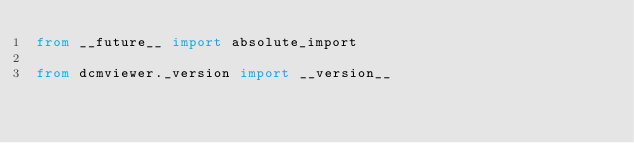<code> <loc_0><loc_0><loc_500><loc_500><_Python_>from __future__ import absolute_import

from dcmviewer._version import __version__
</code> 